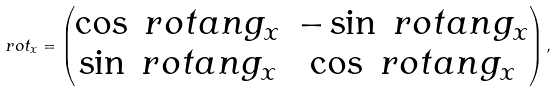Convert formula to latex. <formula><loc_0><loc_0><loc_500><loc_500>\ r o t _ { x } = \begin{pmatrix} \cos { \ r o t a n g _ { x } } & - \sin { \ r o t a n g _ { x } } \\ \sin { \ r o t a n g _ { x } } & \cos { \ r o t a n g _ { x } } \end{pmatrix} ,</formula> 